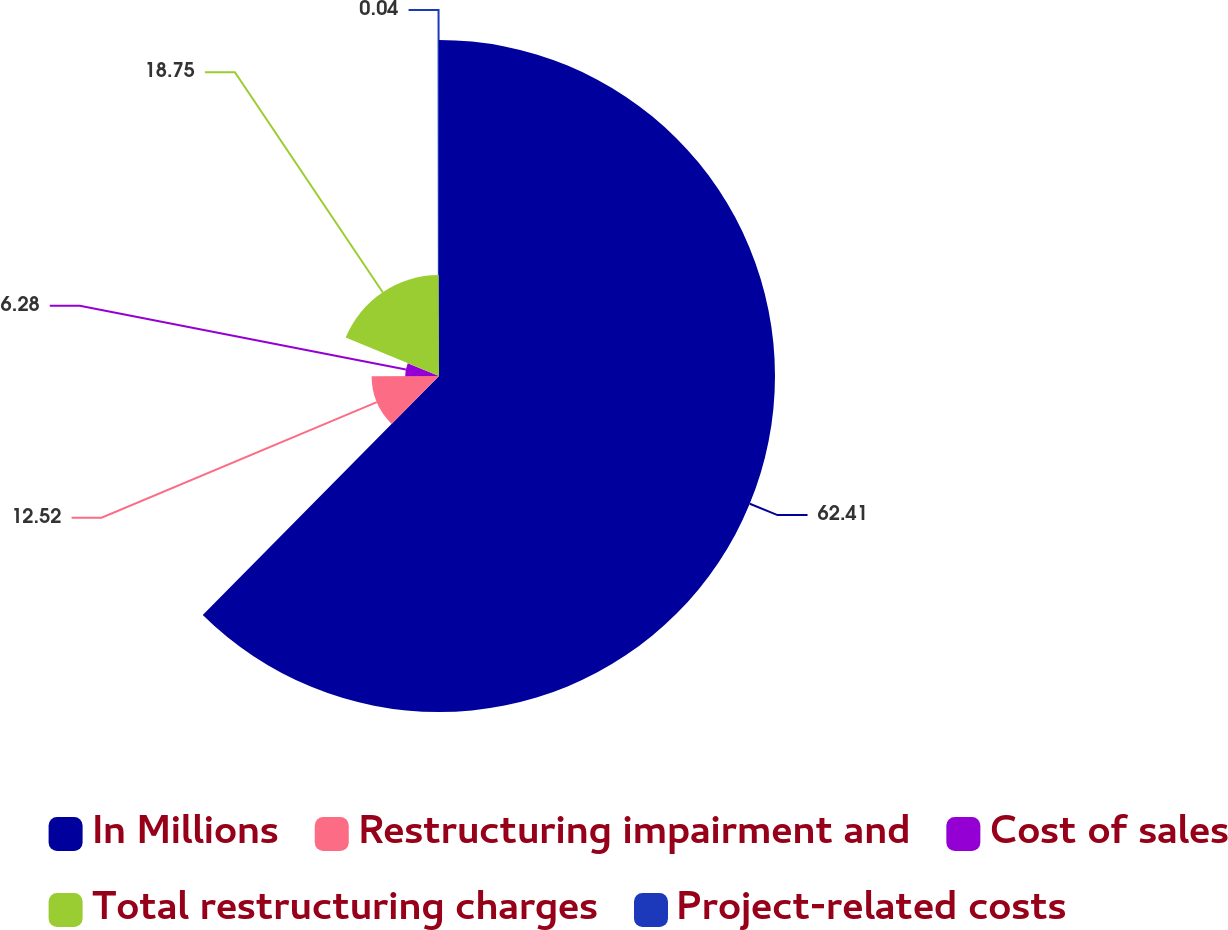Convert chart. <chart><loc_0><loc_0><loc_500><loc_500><pie_chart><fcel>In Millions<fcel>Restructuring impairment and<fcel>Cost of sales<fcel>Total restructuring charges<fcel>Project-related costs<nl><fcel>62.41%<fcel>12.52%<fcel>6.28%<fcel>18.75%<fcel>0.04%<nl></chart> 